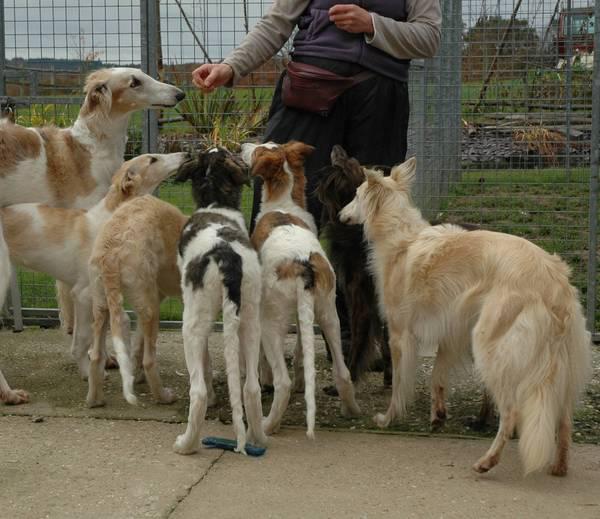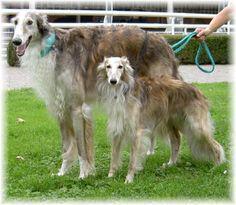The first image is the image on the left, the second image is the image on the right. For the images displayed, is the sentence "there are two dogs standing in the grass with a wall behind them" factually correct? Answer yes or no. Yes. The first image is the image on the left, the second image is the image on the right. For the images displayed, is the sentence "In one image, there are two dogs standing next to each other with their bodies facing the left." factually correct? Answer yes or no. Yes. 